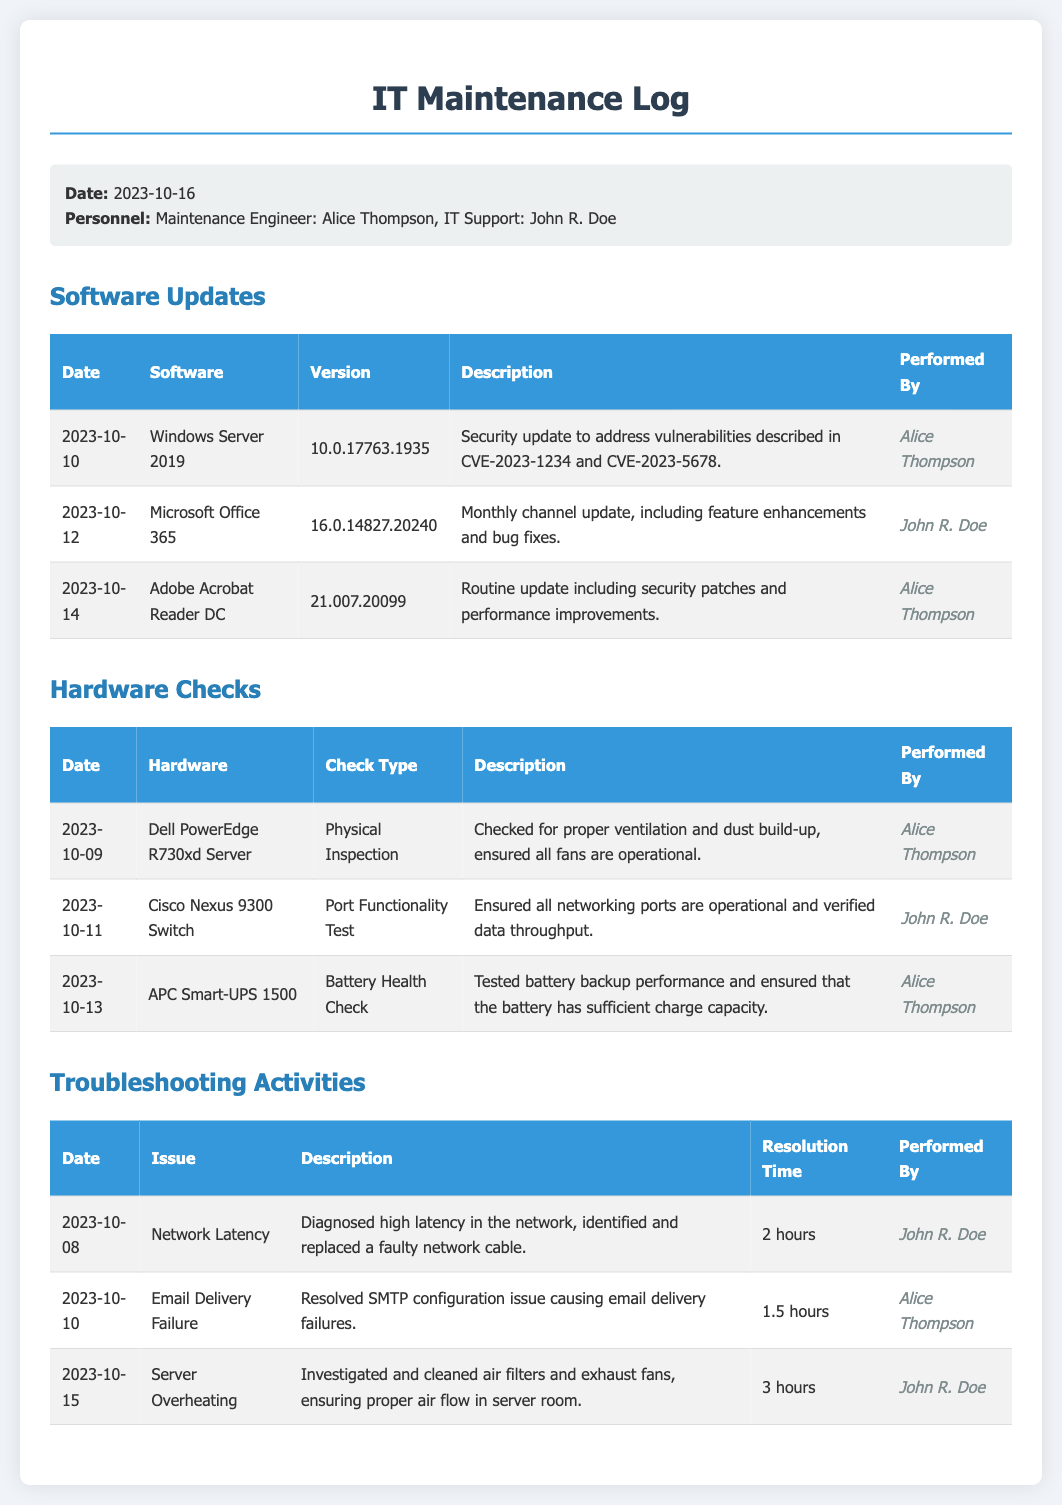What is the date of the IT Maintenance Log? The date of the log is provided in the meta-info section of the document.
Answer: 2023-10-16 Who performed the software update for Adobe Acrobat Reader DC? The performed by column in the software updates section indicates who carried out each update.
Answer: Alice Thompson What was the resolution time for the Email Delivery Failure issue? The resolution time can be found in the troubleshooting activities table under the respective issue.
Answer: 1.5 hours What was the check type for the Dell PowerEdge R730xd Server? The check type is listed in the hardware checks table next to the hardware evaluated.
Answer: Physical Inspection How many software updates were listed in the document? The number of updates can be counted from the software updates table provided in the document.
Answer: 3 What issue did John R. Doe troubleshoot on 2023-10-15? The specific issue is detailed in the troubleshooting activities section with corresponding dates.
Answer: Server Overheating What version of Microsoft Office 365 was updated? The version is mentioned in the software updates table corresponding to Microsoft Office 365.
Answer: 16.0.14827.20240 Who conducted the Battery Health Check for the APC Smart-UPS 1500? The information about who performed each hardware check is listed in the respective column of the table.
Answer: Alice Thompson What is the description of the security update for Windows Server 2019? The description for each software update is included in the software updates table.
Answer: Security update to address vulnerabilities described in CVE-2023-1234 and CVE-2023-5678 